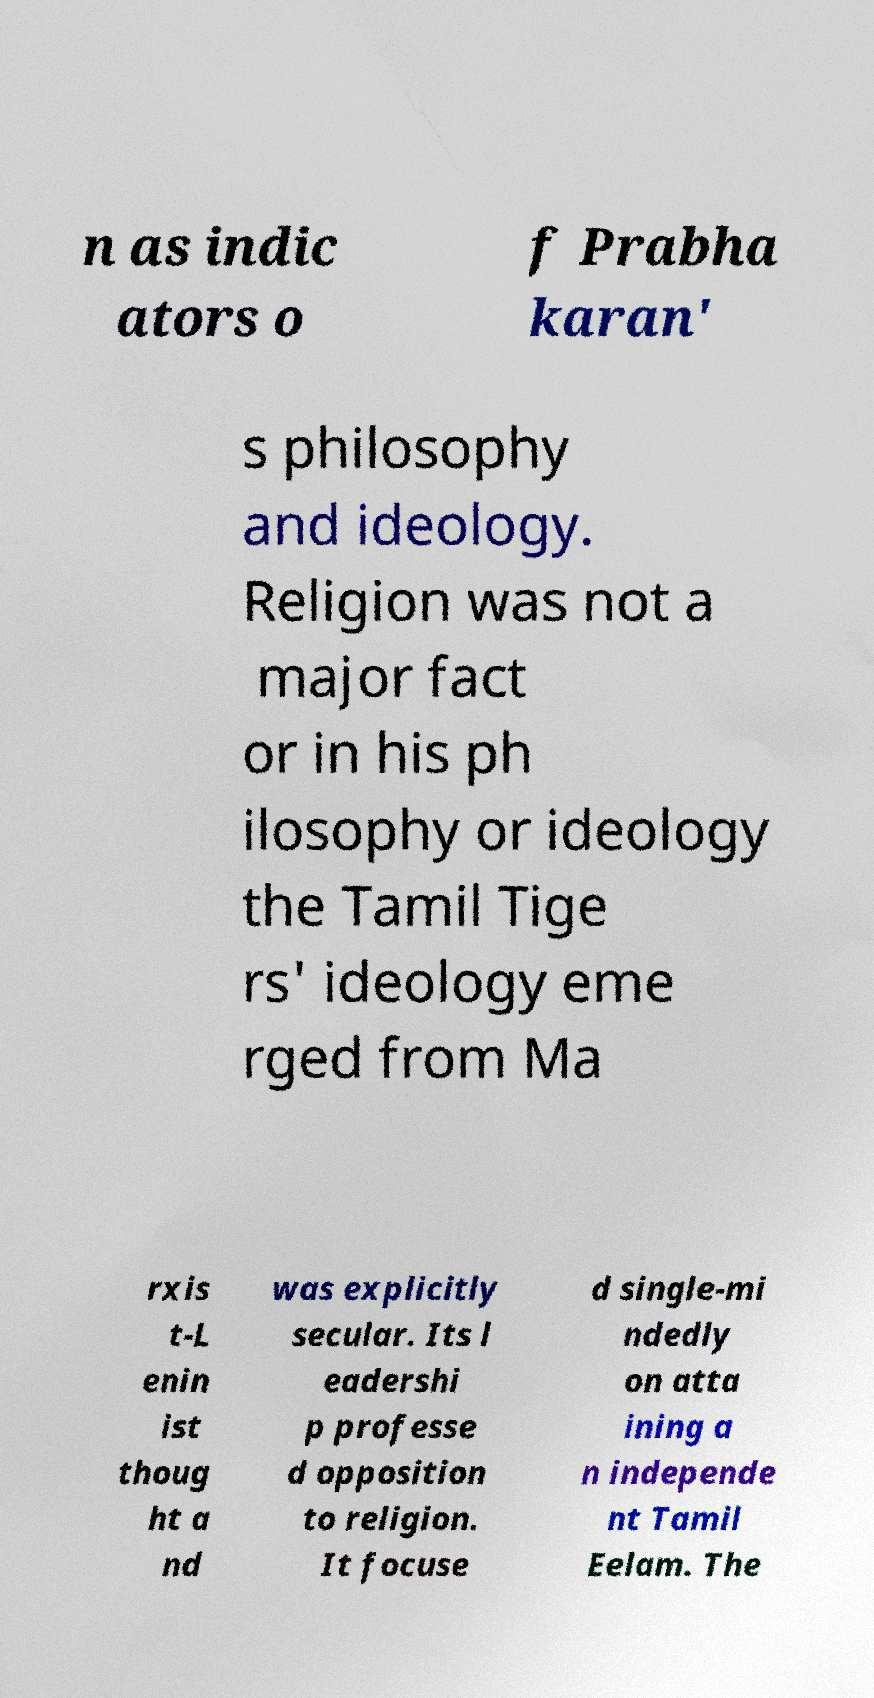Could you assist in decoding the text presented in this image and type it out clearly? n as indic ators o f Prabha karan' s philosophy and ideology. Religion was not a major fact or in his ph ilosophy or ideology the Tamil Tige rs' ideology eme rged from Ma rxis t-L enin ist thoug ht a nd was explicitly secular. Its l eadershi p professe d opposition to religion. It focuse d single-mi ndedly on atta ining a n independe nt Tamil Eelam. The 